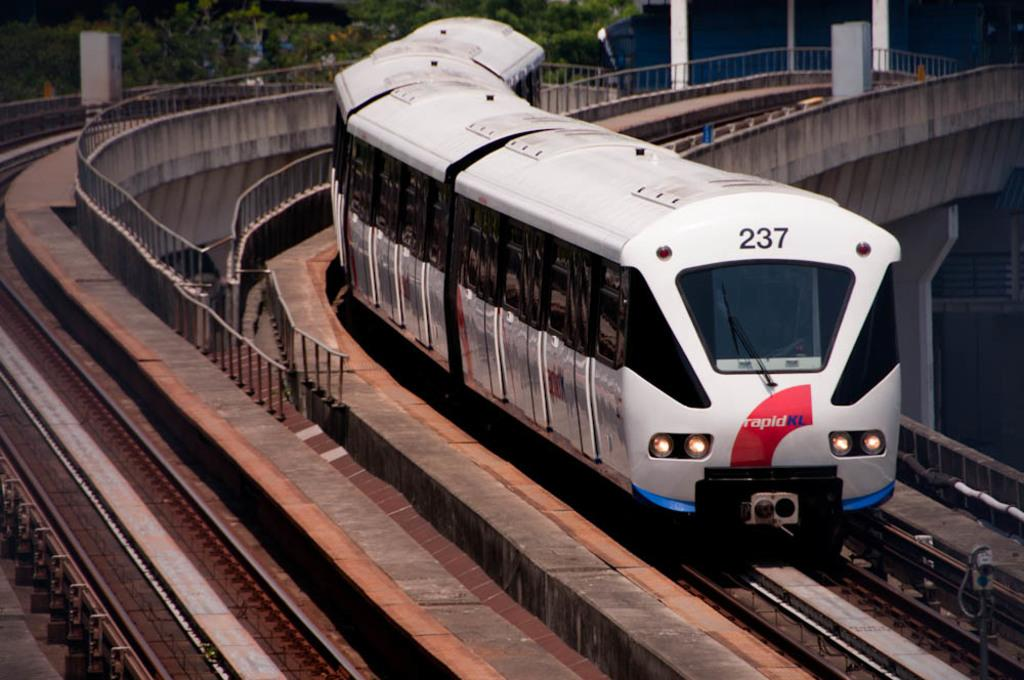<image>
Present a compact description of the photo's key features. a train on a track that says the number 237 on it 